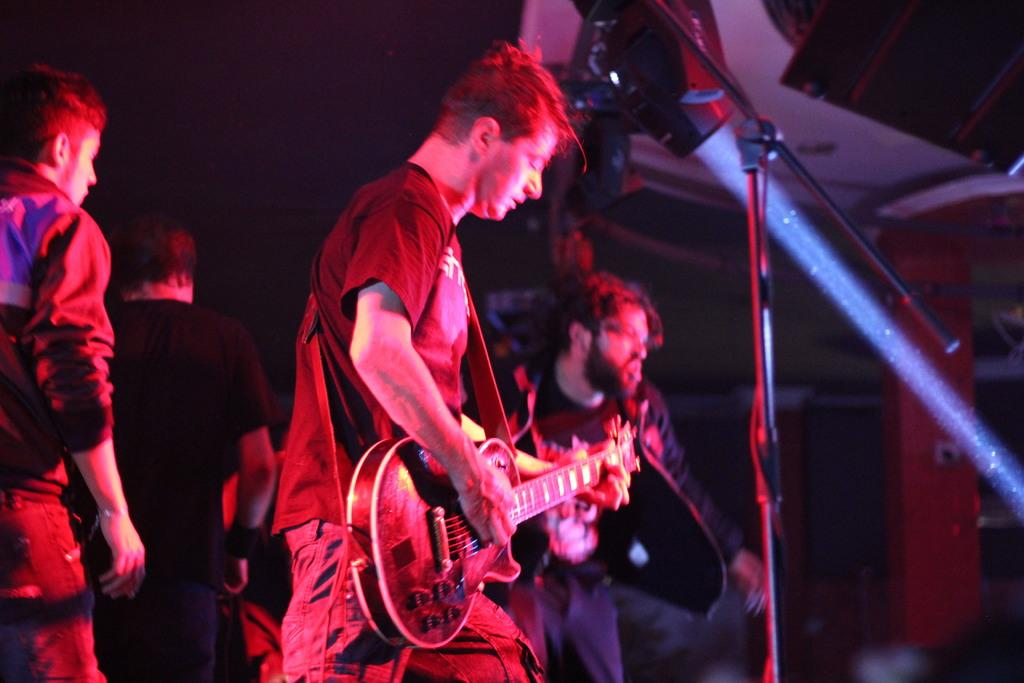What are the men in the image doing? The men are standing in the image. What object is one of the men holding? One of the men is holding a guitar. What can be seen on the right side of the image? There is a mic stand and a light on the right side of the image. Can you see a yak in the image? No, there is no yak present in the image. What type of whip is being used by the men in the image? There is no whip visible in the image; the men are not using any whips. 